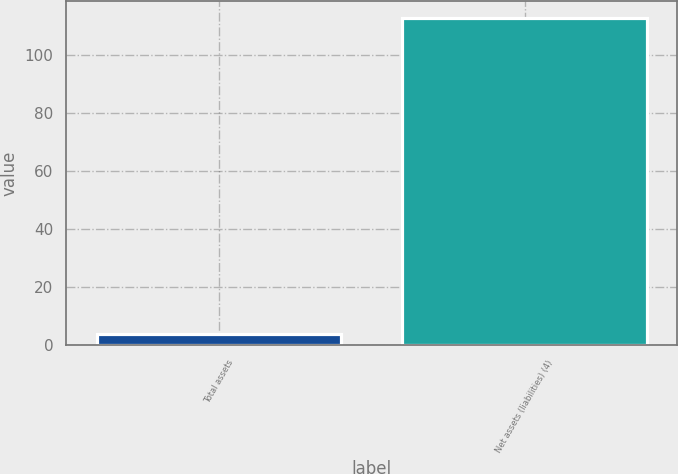Convert chart. <chart><loc_0><loc_0><loc_500><loc_500><bar_chart><fcel>Total assets<fcel>Net assets (liabilities) (4)<nl><fcel>4<fcel>113<nl></chart> 